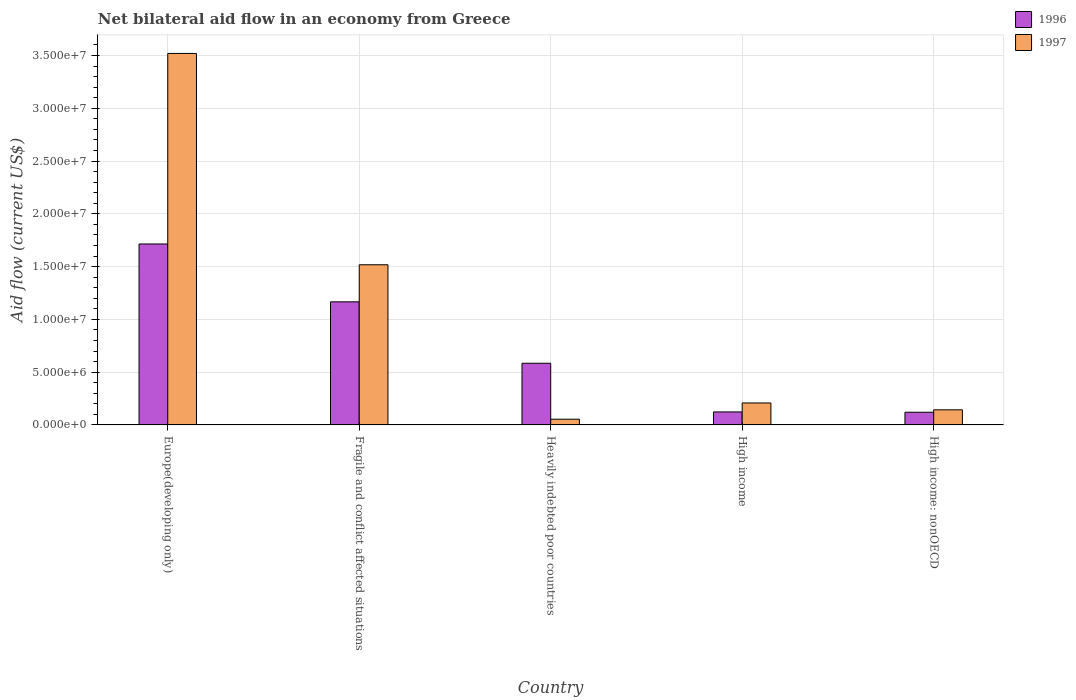How many different coloured bars are there?
Provide a succinct answer. 2. How many groups of bars are there?
Make the answer very short. 5. Are the number of bars per tick equal to the number of legend labels?
Provide a succinct answer. Yes. Are the number of bars on each tick of the X-axis equal?
Your answer should be compact. Yes. How many bars are there on the 1st tick from the left?
Your answer should be compact. 2. What is the label of the 5th group of bars from the left?
Your answer should be very brief. High income: nonOECD. In how many cases, is the number of bars for a given country not equal to the number of legend labels?
Make the answer very short. 0. What is the net bilateral aid flow in 1996 in High income?
Provide a succinct answer. 1.23e+06. Across all countries, what is the maximum net bilateral aid flow in 1996?
Your response must be concise. 1.71e+07. Across all countries, what is the minimum net bilateral aid flow in 1997?
Offer a very short reply. 5.40e+05. In which country was the net bilateral aid flow in 1997 maximum?
Give a very brief answer. Europe(developing only). In which country was the net bilateral aid flow in 1997 minimum?
Your response must be concise. Heavily indebted poor countries. What is the total net bilateral aid flow in 1996 in the graph?
Offer a very short reply. 3.71e+07. What is the difference between the net bilateral aid flow in 1996 in Europe(developing only) and that in Heavily indebted poor countries?
Offer a terse response. 1.13e+07. What is the difference between the net bilateral aid flow in 1997 in High income: nonOECD and the net bilateral aid flow in 1996 in Europe(developing only)?
Ensure brevity in your answer.  -1.57e+07. What is the average net bilateral aid flow in 1997 per country?
Offer a terse response. 1.09e+07. What is the difference between the net bilateral aid flow of/in 1996 and net bilateral aid flow of/in 1997 in Heavily indebted poor countries?
Your answer should be very brief. 5.30e+06. In how many countries, is the net bilateral aid flow in 1996 greater than 31000000 US$?
Provide a succinct answer. 0. What is the ratio of the net bilateral aid flow in 1997 in Fragile and conflict affected situations to that in High income: nonOECD?
Your answer should be compact. 10.61. Is the net bilateral aid flow in 1996 in Europe(developing only) less than that in High income?
Make the answer very short. No. Is the difference between the net bilateral aid flow in 1996 in Heavily indebted poor countries and High income: nonOECD greater than the difference between the net bilateral aid flow in 1997 in Heavily indebted poor countries and High income: nonOECD?
Offer a terse response. Yes. What is the difference between the highest and the second highest net bilateral aid flow in 1996?
Provide a short and direct response. 5.48e+06. What is the difference between the highest and the lowest net bilateral aid flow in 1996?
Provide a short and direct response. 1.59e+07. What does the 2nd bar from the left in High income: nonOECD represents?
Your response must be concise. 1997. Are all the bars in the graph horizontal?
Your answer should be compact. No. What is the difference between two consecutive major ticks on the Y-axis?
Make the answer very short. 5.00e+06. Are the values on the major ticks of Y-axis written in scientific E-notation?
Make the answer very short. Yes. Does the graph contain any zero values?
Your answer should be compact. No. How many legend labels are there?
Make the answer very short. 2. How are the legend labels stacked?
Keep it short and to the point. Vertical. What is the title of the graph?
Offer a very short reply. Net bilateral aid flow in an economy from Greece. What is the Aid flow (current US$) of 1996 in Europe(developing only)?
Your answer should be compact. 1.71e+07. What is the Aid flow (current US$) in 1997 in Europe(developing only)?
Keep it short and to the point. 3.52e+07. What is the Aid flow (current US$) in 1996 in Fragile and conflict affected situations?
Make the answer very short. 1.17e+07. What is the Aid flow (current US$) in 1997 in Fragile and conflict affected situations?
Offer a very short reply. 1.52e+07. What is the Aid flow (current US$) of 1996 in Heavily indebted poor countries?
Keep it short and to the point. 5.84e+06. What is the Aid flow (current US$) of 1997 in Heavily indebted poor countries?
Your answer should be very brief. 5.40e+05. What is the Aid flow (current US$) of 1996 in High income?
Ensure brevity in your answer.  1.23e+06. What is the Aid flow (current US$) of 1997 in High income?
Provide a short and direct response. 2.08e+06. What is the Aid flow (current US$) of 1996 in High income: nonOECD?
Your answer should be very brief. 1.20e+06. What is the Aid flow (current US$) in 1997 in High income: nonOECD?
Provide a succinct answer. 1.43e+06. Across all countries, what is the maximum Aid flow (current US$) in 1996?
Offer a very short reply. 1.71e+07. Across all countries, what is the maximum Aid flow (current US$) in 1997?
Ensure brevity in your answer.  3.52e+07. Across all countries, what is the minimum Aid flow (current US$) in 1996?
Make the answer very short. 1.20e+06. Across all countries, what is the minimum Aid flow (current US$) of 1997?
Your answer should be compact. 5.40e+05. What is the total Aid flow (current US$) of 1996 in the graph?
Provide a short and direct response. 3.71e+07. What is the total Aid flow (current US$) of 1997 in the graph?
Offer a very short reply. 5.44e+07. What is the difference between the Aid flow (current US$) of 1996 in Europe(developing only) and that in Fragile and conflict affected situations?
Your response must be concise. 5.48e+06. What is the difference between the Aid flow (current US$) of 1997 in Europe(developing only) and that in Fragile and conflict affected situations?
Provide a short and direct response. 2.00e+07. What is the difference between the Aid flow (current US$) in 1996 in Europe(developing only) and that in Heavily indebted poor countries?
Offer a very short reply. 1.13e+07. What is the difference between the Aid flow (current US$) in 1997 in Europe(developing only) and that in Heavily indebted poor countries?
Give a very brief answer. 3.46e+07. What is the difference between the Aid flow (current US$) in 1996 in Europe(developing only) and that in High income?
Keep it short and to the point. 1.59e+07. What is the difference between the Aid flow (current US$) in 1997 in Europe(developing only) and that in High income?
Offer a very short reply. 3.31e+07. What is the difference between the Aid flow (current US$) in 1996 in Europe(developing only) and that in High income: nonOECD?
Ensure brevity in your answer.  1.59e+07. What is the difference between the Aid flow (current US$) of 1997 in Europe(developing only) and that in High income: nonOECD?
Your answer should be compact. 3.38e+07. What is the difference between the Aid flow (current US$) in 1996 in Fragile and conflict affected situations and that in Heavily indebted poor countries?
Make the answer very short. 5.82e+06. What is the difference between the Aid flow (current US$) in 1997 in Fragile and conflict affected situations and that in Heavily indebted poor countries?
Your answer should be very brief. 1.46e+07. What is the difference between the Aid flow (current US$) of 1996 in Fragile and conflict affected situations and that in High income?
Offer a terse response. 1.04e+07. What is the difference between the Aid flow (current US$) of 1997 in Fragile and conflict affected situations and that in High income?
Offer a very short reply. 1.31e+07. What is the difference between the Aid flow (current US$) in 1996 in Fragile and conflict affected situations and that in High income: nonOECD?
Offer a terse response. 1.05e+07. What is the difference between the Aid flow (current US$) of 1997 in Fragile and conflict affected situations and that in High income: nonOECD?
Ensure brevity in your answer.  1.37e+07. What is the difference between the Aid flow (current US$) in 1996 in Heavily indebted poor countries and that in High income?
Keep it short and to the point. 4.61e+06. What is the difference between the Aid flow (current US$) of 1997 in Heavily indebted poor countries and that in High income?
Offer a terse response. -1.54e+06. What is the difference between the Aid flow (current US$) in 1996 in Heavily indebted poor countries and that in High income: nonOECD?
Offer a terse response. 4.64e+06. What is the difference between the Aid flow (current US$) of 1997 in Heavily indebted poor countries and that in High income: nonOECD?
Offer a terse response. -8.90e+05. What is the difference between the Aid flow (current US$) in 1997 in High income and that in High income: nonOECD?
Provide a short and direct response. 6.50e+05. What is the difference between the Aid flow (current US$) in 1996 in Europe(developing only) and the Aid flow (current US$) in 1997 in Fragile and conflict affected situations?
Make the answer very short. 1.97e+06. What is the difference between the Aid flow (current US$) of 1996 in Europe(developing only) and the Aid flow (current US$) of 1997 in Heavily indebted poor countries?
Ensure brevity in your answer.  1.66e+07. What is the difference between the Aid flow (current US$) of 1996 in Europe(developing only) and the Aid flow (current US$) of 1997 in High income?
Make the answer very short. 1.51e+07. What is the difference between the Aid flow (current US$) in 1996 in Europe(developing only) and the Aid flow (current US$) in 1997 in High income: nonOECD?
Your answer should be compact. 1.57e+07. What is the difference between the Aid flow (current US$) of 1996 in Fragile and conflict affected situations and the Aid flow (current US$) of 1997 in Heavily indebted poor countries?
Give a very brief answer. 1.11e+07. What is the difference between the Aid flow (current US$) of 1996 in Fragile and conflict affected situations and the Aid flow (current US$) of 1997 in High income?
Offer a very short reply. 9.58e+06. What is the difference between the Aid flow (current US$) of 1996 in Fragile and conflict affected situations and the Aid flow (current US$) of 1997 in High income: nonOECD?
Provide a succinct answer. 1.02e+07. What is the difference between the Aid flow (current US$) of 1996 in Heavily indebted poor countries and the Aid flow (current US$) of 1997 in High income?
Ensure brevity in your answer.  3.76e+06. What is the difference between the Aid flow (current US$) of 1996 in Heavily indebted poor countries and the Aid flow (current US$) of 1997 in High income: nonOECD?
Provide a succinct answer. 4.41e+06. What is the average Aid flow (current US$) of 1996 per country?
Provide a succinct answer. 7.41e+06. What is the average Aid flow (current US$) of 1997 per country?
Your response must be concise. 1.09e+07. What is the difference between the Aid flow (current US$) of 1996 and Aid flow (current US$) of 1997 in Europe(developing only)?
Provide a short and direct response. -1.80e+07. What is the difference between the Aid flow (current US$) of 1996 and Aid flow (current US$) of 1997 in Fragile and conflict affected situations?
Give a very brief answer. -3.51e+06. What is the difference between the Aid flow (current US$) of 1996 and Aid flow (current US$) of 1997 in Heavily indebted poor countries?
Offer a terse response. 5.30e+06. What is the difference between the Aid flow (current US$) of 1996 and Aid flow (current US$) of 1997 in High income?
Keep it short and to the point. -8.50e+05. What is the difference between the Aid flow (current US$) of 1996 and Aid flow (current US$) of 1997 in High income: nonOECD?
Give a very brief answer. -2.30e+05. What is the ratio of the Aid flow (current US$) in 1996 in Europe(developing only) to that in Fragile and conflict affected situations?
Your response must be concise. 1.47. What is the ratio of the Aid flow (current US$) in 1997 in Europe(developing only) to that in Fragile and conflict affected situations?
Your answer should be very brief. 2.32. What is the ratio of the Aid flow (current US$) of 1996 in Europe(developing only) to that in Heavily indebted poor countries?
Provide a succinct answer. 2.93. What is the ratio of the Aid flow (current US$) in 1997 in Europe(developing only) to that in Heavily indebted poor countries?
Provide a short and direct response. 65.17. What is the ratio of the Aid flow (current US$) in 1996 in Europe(developing only) to that in High income?
Your answer should be compact. 13.94. What is the ratio of the Aid flow (current US$) in 1997 in Europe(developing only) to that in High income?
Your response must be concise. 16.92. What is the ratio of the Aid flow (current US$) of 1996 in Europe(developing only) to that in High income: nonOECD?
Give a very brief answer. 14.28. What is the ratio of the Aid flow (current US$) in 1997 in Europe(developing only) to that in High income: nonOECD?
Offer a terse response. 24.61. What is the ratio of the Aid flow (current US$) of 1996 in Fragile and conflict affected situations to that in Heavily indebted poor countries?
Ensure brevity in your answer.  2. What is the ratio of the Aid flow (current US$) of 1997 in Fragile and conflict affected situations to that in Heavily indebted poor countries?
Provide a short and direct response. 28.09. What is the ratio of the Aid flow (current US$) of 1996 in Fragile and conflict affected situations to that in High income?
Make the answer very short. 9.48. What is the ratio of the Aid flow (current US$) in 1997 in Fragile and conflict affected situations to that in High income?
Ensure brevity in your answer.  7.29. What is the ratio of the Aid flow (current US$) of 1996 in Fragile and conflict affected situations to that in High income: nonOECD?
Make the answer very short. 9.72. What is the ratio of the Aid flow (current US$) in 1997 in Fragile and conflict affected situations to that in High income: nonOECD?
Your answer should be very brief. 10.61. What is the ratio of the Aid flow (current US$) in 1996 in Heavily indebted poor countries to that in High income?
Keep it short and to the point. 4.75. What is the ratio of the Aid flow (current US$) in 1997 in Heavily indebted poor countries to that in High income?
Offer a terse response. 0.26. What is the ratio of the Aid flow (current US$) in 1996 in Heavily indebted poor countries to that in High income: nonOECD?
Offer a very short reply. 4.87. What is the ratio of the Aid flow (current US$) in 1997 in Heavily indebted poor countries to that in High income: nonOECD?
Keep it short and to the point. 0.38. What is the ratio of the Aid flow (current US$) of 1996 in High income to that in High income: nonOECD?
Offer a very short reply. 1.02. What is the ratio of the Aid flow (current US$) of 1997 in High income to that in High income: nonOECD?
Provide a short and direct response. 1.45. What is the difference between the highest and the second highest Aid flow (current US$) of 1996?
Your response must be concise. 5.48e+06. What is the difference between the highest and the second highest Aid flow (current US$) in 1997?
Your answer should be very brief. 2.00e+07. What is the difference between the highest and the lowest Aid flow (current US$) in 1996?
Your answer should be very brief. 1.59e+07. What is the difference between the highest and the lowest Aid flow (current US$) in 1997?
Provide a succinct answer. 3.46e+07. 